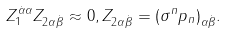<formula> <loc_0><loc_0><loc_500><loc_500>Z _ { 1 } ^ { \dot { \alpha } \alpha } Z _ { 2 \alpha \dot { \beta } } \approx 0 , Z _ { 2 \alpha \dot { \beta } } = ( \sigma ^ { n } p _ { n } ) _ { \alpha \dot { \beta } } .</formula> 